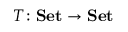Convert formula to latex. <formula><loc_0><loc_0><loc_500><loc_500>T \colon S e t \to S e t</formula> 